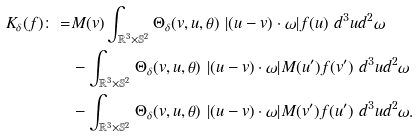<formula> <loc_0><loc_0><loc_500><loc_500>K _ { \delta } ( f ) \colon = & M ( v ) \int _ { \mathbb { R } ^ { 3 } \times \mathbb { S } ^ { 2 } } \Theta _ { \delta } ( v , u , \theta ) \ | ( u - v ) \cdot \omega | f ( u ) \ d ^ { 3 } u d ^ { 2 } \omega \\ & - \int _ { \mathbb { R } ^ { 3 } \times \mathbb { S } ^ { 2 } } \Theta _ { \delta } ( v , u , \theta ) \ | ( u - v ) \cdot \omega | M ( u ^ { \prime } ) f ( v ^ { \prime } ) \ d ^ { 3 } u d ^ { 2 } \omega \\ & - \int _ { \mathbb { R } ^ { 3 } \times \mathbb { S } ^ { 2 } } \Theta _ { \delta } ( v , u , \theta ) \ | ( u - v ) \cdot \omega | M ( v ^ { \prime } ) f ( u ^ { \prime } ) \ d ^ { 3 } u d ^ { 2 } \omega .</formula> 